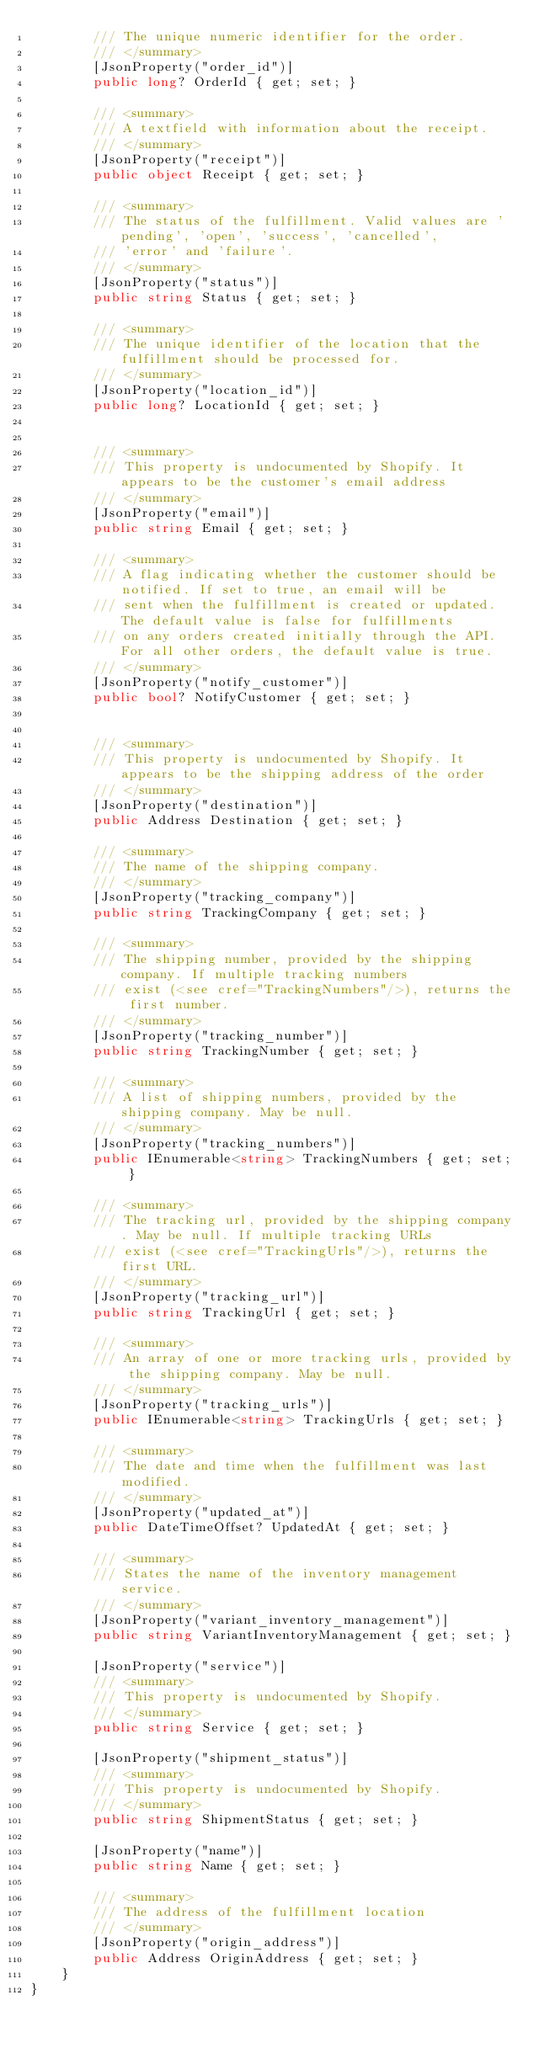Convert code to text. <code><loc_0><loc_0><loc_500><loc_500><_C#_>        /// The unique numeric identifier for the order.
        /// </summary>
        [JsonProperty("order_id")]
        public long? OrderId { get; set; }

        /// <summary>
        /// A textfield with information about the receipt.
        /// </summary>
        [JsonProperty("receipt")]
        public object Receipt { get; set; }

        /// <summary>
        /// The status of the fulfillment. Valid values are 'pending', 'open', 'success', 'cancelled',
        /// 'error' and 'failure'.
        /// </summary>
        [JsonProperty("status")]
        public string Status { get; set; }

        /// <summary>
        /// The unique identifier of the location that the fulfillment should be processed for.
        /// </summary>
        [JsonProperty("location_id")]
        public long? LocationId { get; set; }


        /// <summary>
        /// This property is undocumented by Shopify. It appears to be the customer's email address
        /// </summary>
        [JsonProperty("email")]
        public string Email { get; set; }

        /// <summary>
        /// A flag indicating whether the customer should be notified. If set to true, an email will be
        /// sent when the fulfillment is created or updated. The default value is false for fulfillments
        /// on any orders created initially through the API. For all other orders, the default value is true.
        /// </summary>
        [JsonProperty("notify_customer")]
        public bool? NotifyCustomer { get; set; }


        /// <summary>
        /// This property is undocumented by Shopify. It appears to be the shipping address of the order
        /// </summary>
        [JsonProperty("destination")]
        public Address Destination { get; set; }

        /// <summary>
        /// The name of the shipping company.
        /// </summary>
        [JsonProperty("tracking_company")]
        public string TrackingCompany { get; set; }

        /// <summary>
        /// The shipping number, provided by the shipping company. If multiple tracking numbers
        /// exist (<see cref="TrackingNumbers"/>), returns the first number.
        /// </summary>
        [JsonProperty("tracking_number")]
        public string TrackingNumber { get; set; }

        /// <summary>
        /// A list of shipping numbers, provided by the shipping company. May be null.
        /// </summary>
        [JsonProperty("tracking_numbers")]
        public IEnumerable<string> TrackingNumbers { get; set; }

        /// <summary>
        /// The tracking url, provided by the shipping company. May be null. If multiple tracking URLs
        /// exist (<see cref="TrackingUrls"/>), returns the first URL.
        /// </summary>
        [JsonProperty("tracking_url")]
        public string TrackingUrl { get; set; }

        /// <summary>
        /// An array of one or more tracking urls, provided by the shipping company. May be null.
        /// </summary>
        [JsonProperty("tracking_urls")]
        public IEnumerable<string> TrackingUrls { get; set; }

        /// <summary>
        /// The date and time when the fulfillment was last modified.
        /// </summary>
        [JsonProperty("updated_at")]
        public DateTimeOffset? UpdatedAt { get; set; }

        /// <summary>
        /// States the name of the inventory management service.
        /// </summary>
        [JsonProperty("variant_inventory_management")]
        public string VariantInventoryManagement { get; set; }

        [JsonProperty("service")]
        /// <summary>
        /// This property is undocumented by Shopify.
        /// </summary>
        public string Service { get; set; }

        [JsonProperty("shipment_status")]
        /// <summary>
        /// This property is undocumented by Shopify.
        /// </summary>
        public string ShipmentStatus { get; set; }

        [JsonProperty("name")]
        public string Name { get; set; }

        /// <summary>
        /// The address of the fulfillment location
        /// </summary>
        [JsonProperty("origin_address")]
        public Address OriginAddress { get; set; }
    }
}
</code> 